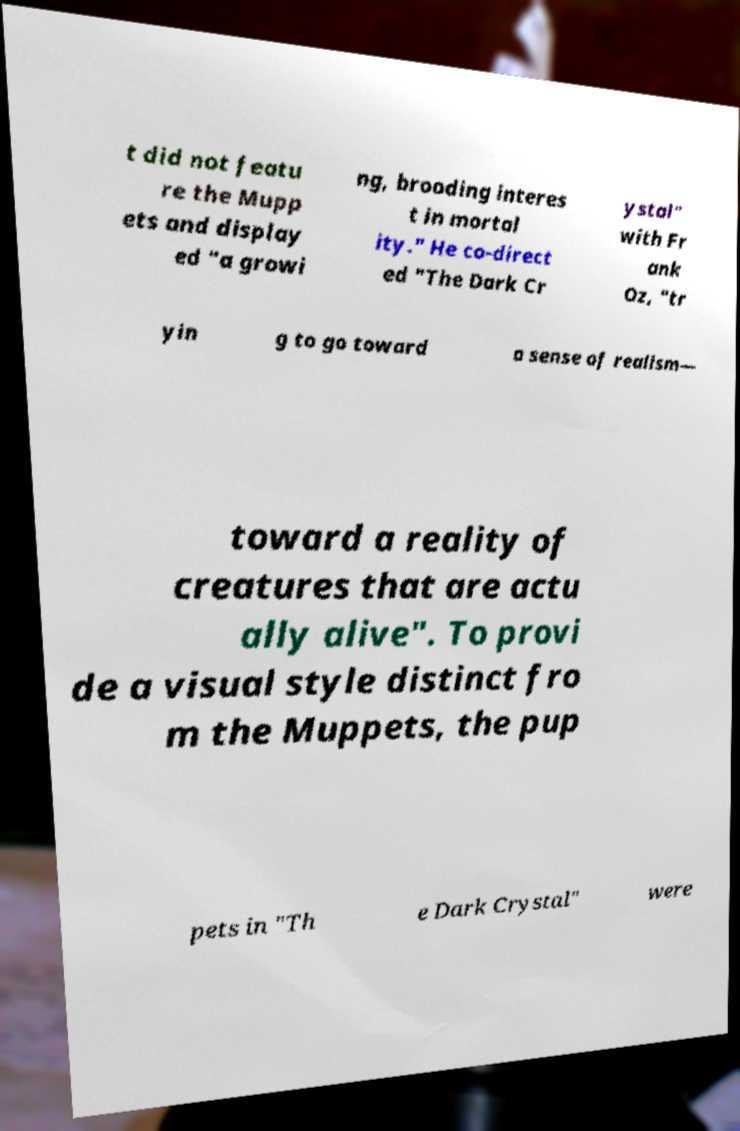Could you assist in decoding the text presented in this image and type it out clearly? t did not featu re the Mupp ets and display ed "a growi ng, brooding interes t in mortal ity." He co-direct ed "The Dark Cr ystal" with Fr ank Oz, "tr yin g to go toward a sense of realism— toward a reality of creatures that are actu ally alive". To provi de a visual style distinct fro m the Muppets, the pup pets in "Th e Dark Crystal" were 